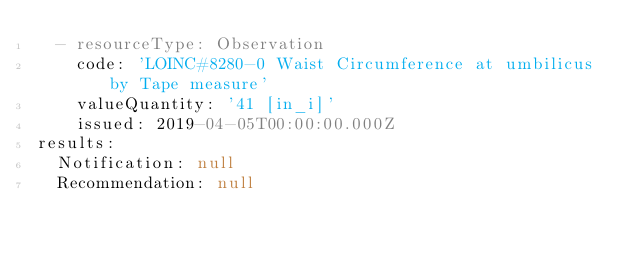<code> <loc_0><loc_0><loc_500><loc_500><_YAML_>  - resourceType: Observation
    code: 'LOINC#8280-0 Waist Circumference at umbilicus by Tape measure'
    valueQuantity: '41 [in_i]'
    issued: 2019-04-05T00:00:00.000Z
results:
  Notification: null
  Recommendation: null
</code> 